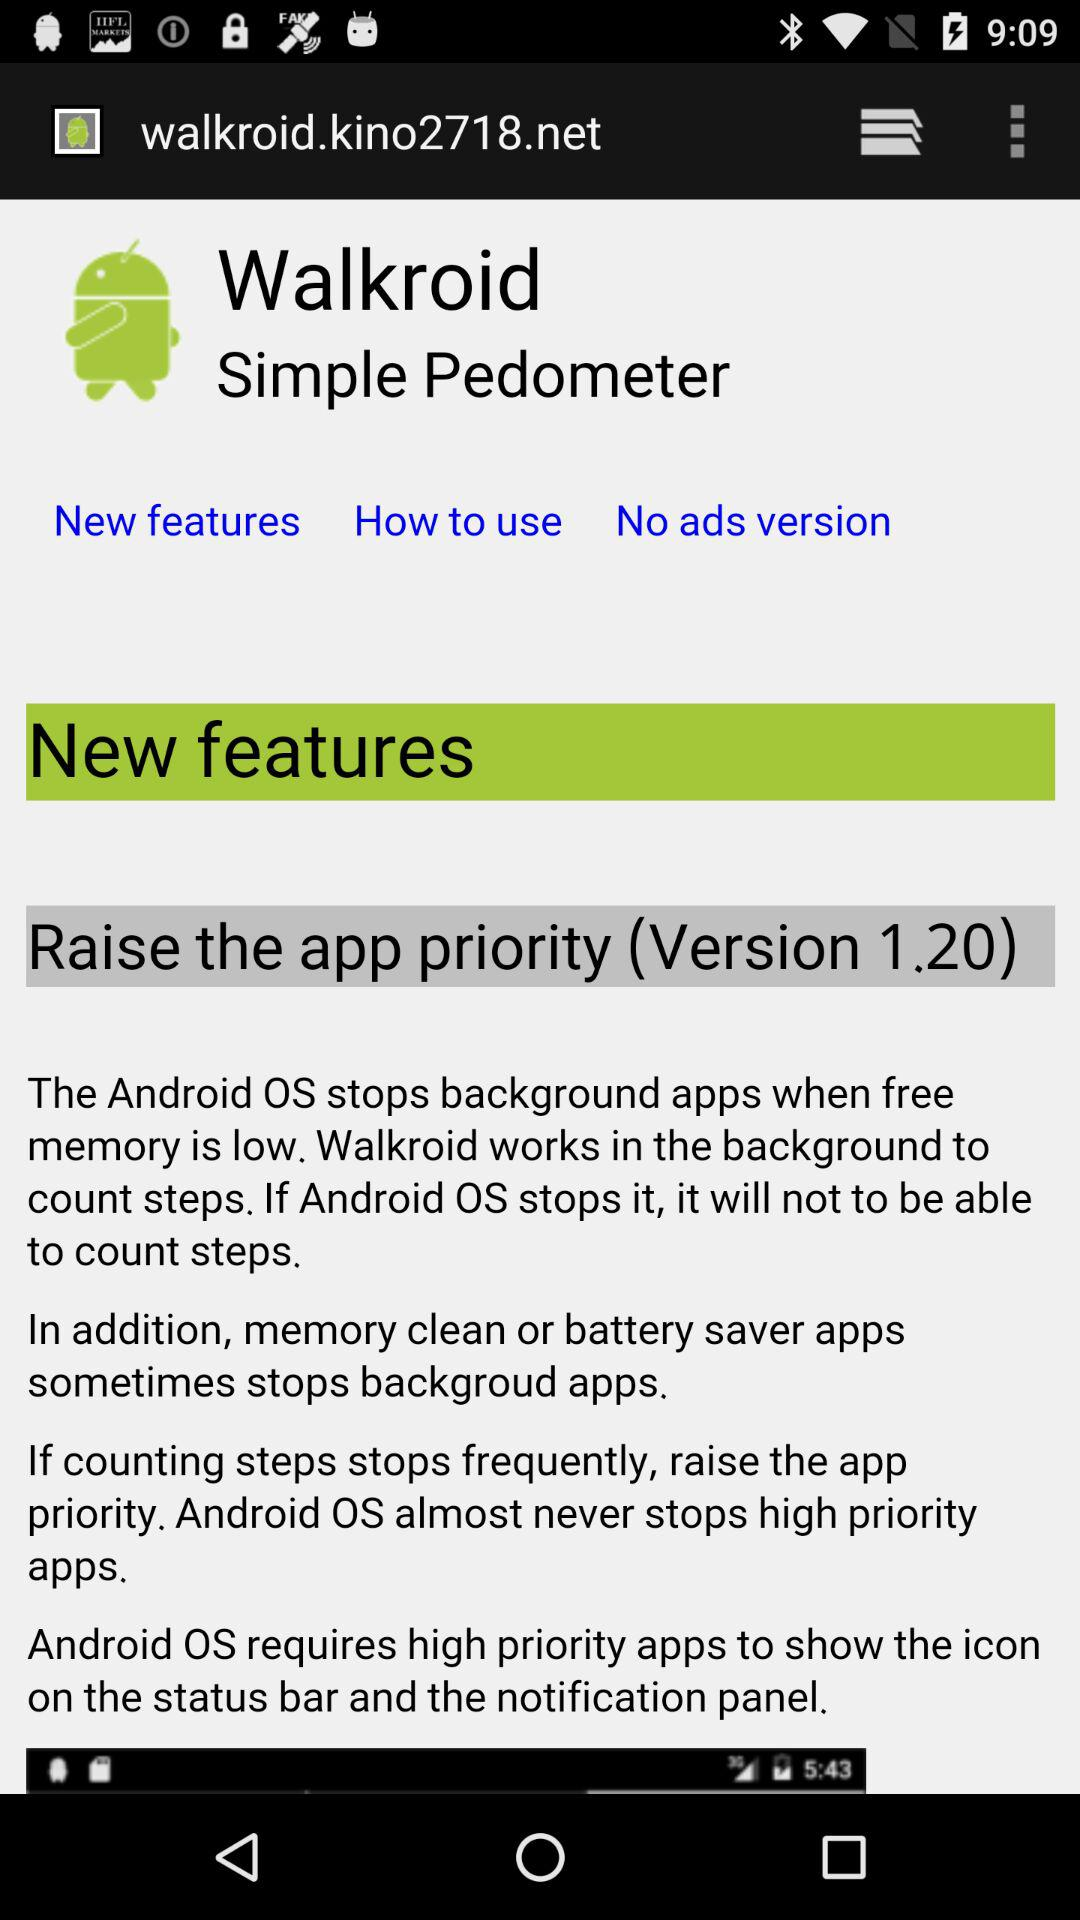What version is used? The used version is 1.20. 